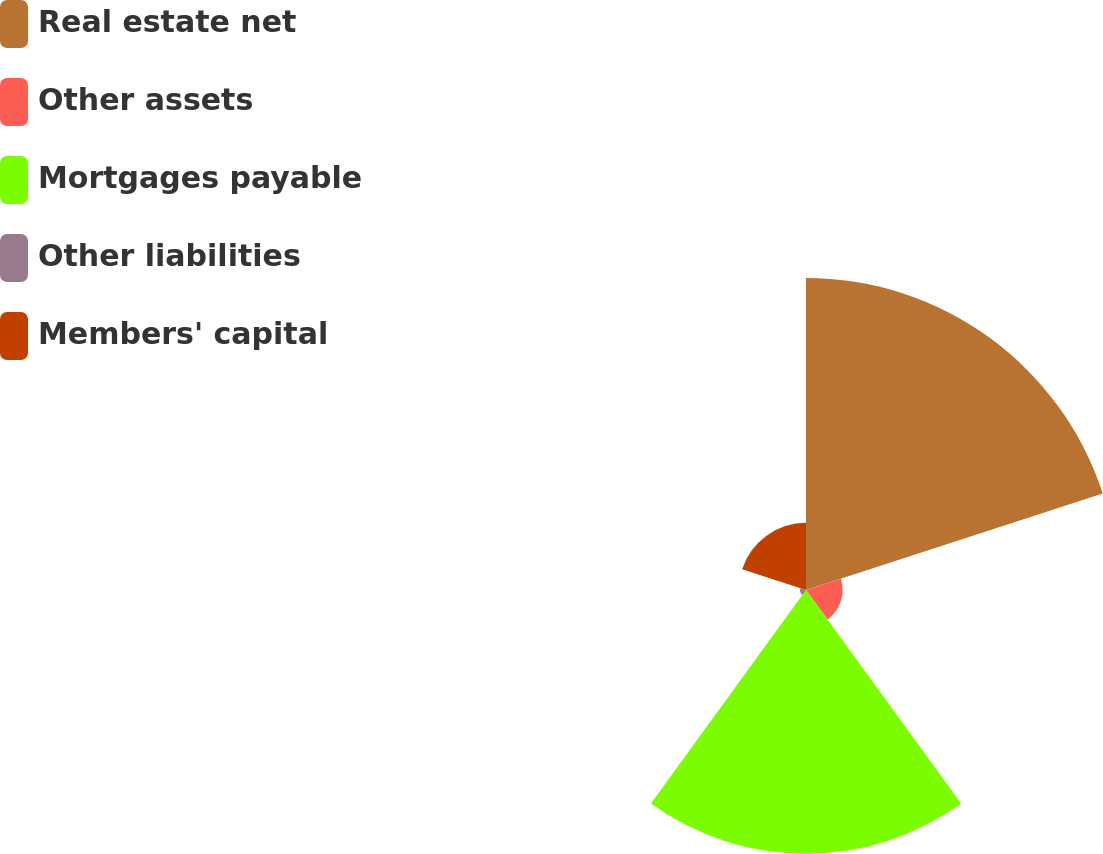<chart> <loc_0><loc_0><loc_500><loc_500><pie_chart><fcel>Real estate net<fcel>Other assets<fcel>Mortgages payable<fcel>Other liabilities<fcel>Members' capital<nl><fcel>45.5%<fcel>5.34%<fcel>38.48%<fcel>0.88%<fcel>9.8%<nl></chart> 